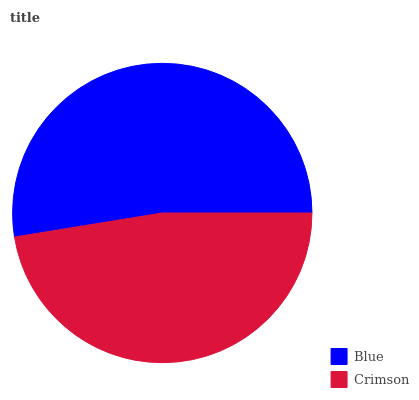Is Crimson the minimum?
Answer yes or no. Yes. Is Blue the maximum?
Answer yes or no. Yes. Is Crimson the maximum?
Answer yes or no. No. Is Blue greater than Crimson?
Answer yes or no. Yes. Is Crimson less than Blue?
Answer yes or no. Yes. Is Crimson greater than Blue?
Answer yes or no. No. Is Blue less than Crimson?
Answer yes or no. No. Is Blue the high median?
Answer yes or no. Yes. Is Crimson the low median?
Answer yes or no. Yes. Is Crimson the high median?
Answer yes or no. No. Is Blue the low median?
Answer yes or no. No. 